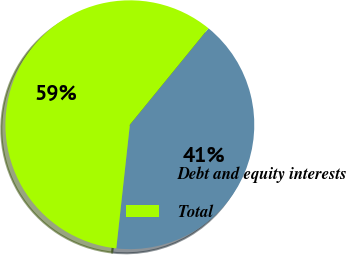Convert chart to OTSL. <chart><loc_0><loc_0><loc_500><loc_500><pie_chart><fcel>Debt and equity interests<fcel>Total<nl><fcel>40.85%<fcel>59.15%<nl></chart> 